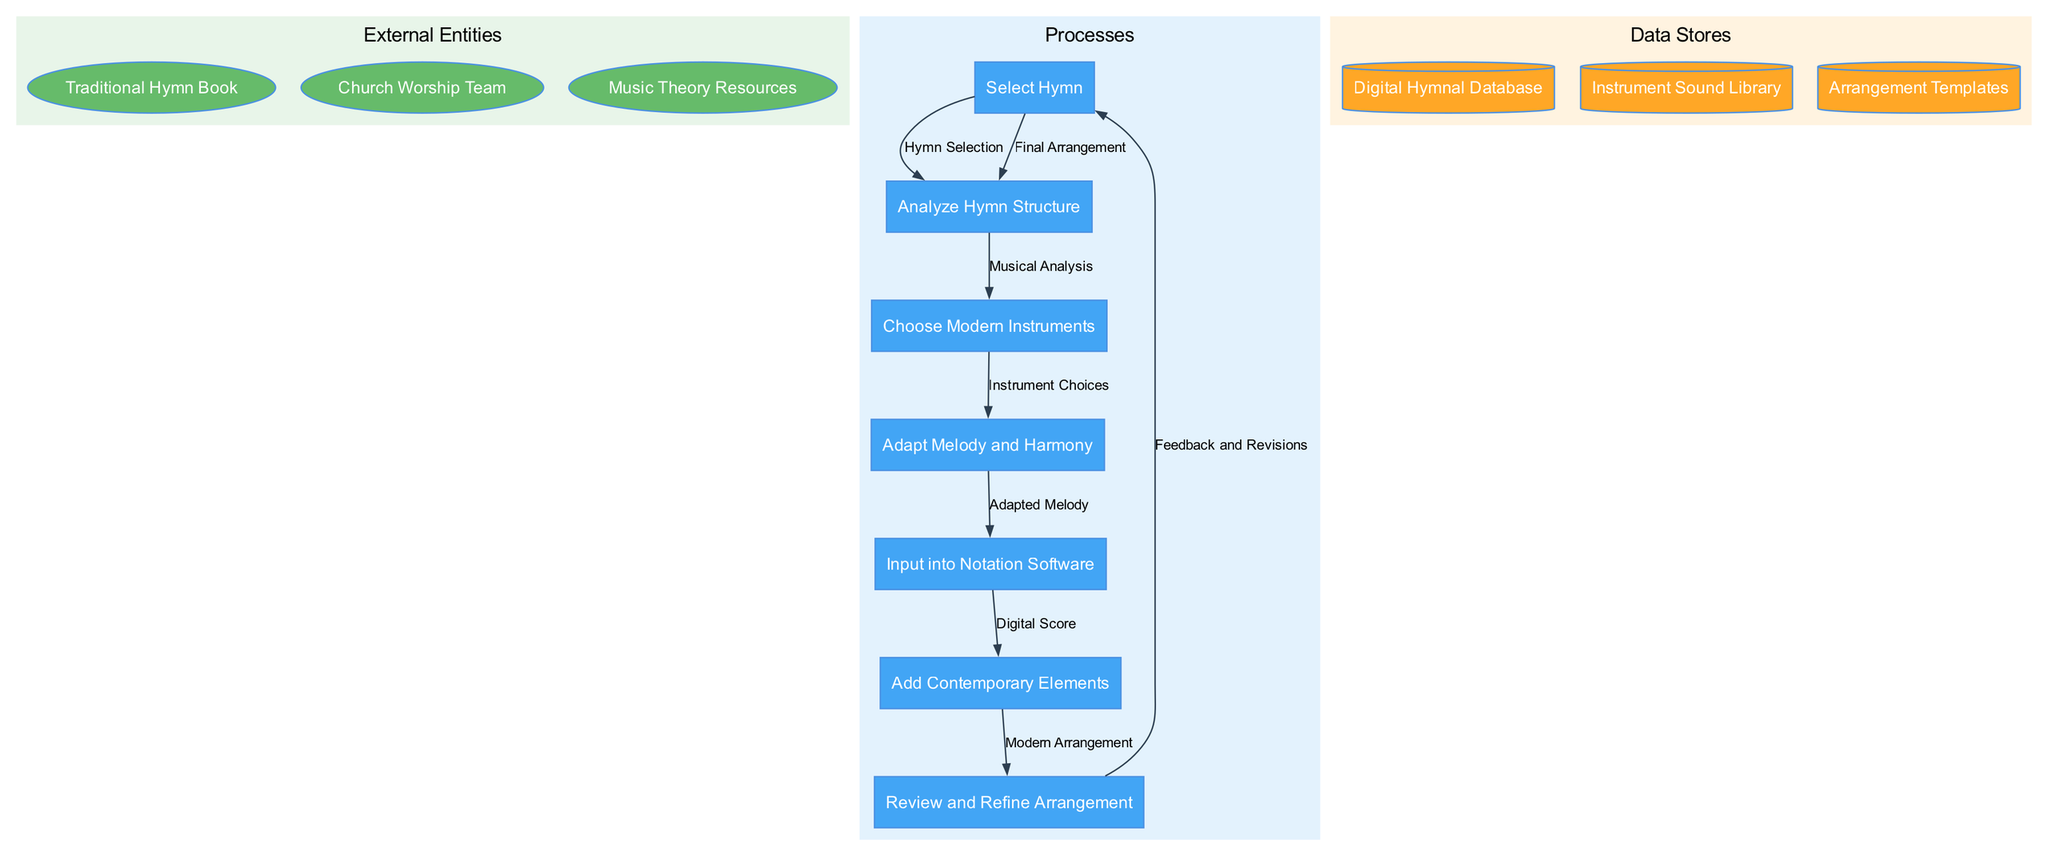What is the first process in the diagram? The first process listed in the diagram is "Select Hymn," which is indicated as the starting point of the flow in the processes cluster.
Answer: Select Hymn How many external entities are present in the diagram? There are three external entities: "Traditional Hymn Book," "Church Worship Team," and "Music Theory Resources." The count can be verified by listing them.
Answer: 3 Which data store is related to modern instrument choices? The "Instrument Sound Library" data store is directly associated with the process of "Choose Modern Instruments." This can be inferred from the connection between this process and the data store.
Answer: Instrument Sound Library What process follows "Adapt Melody and Harmony"? The process that follows "Adapt Melody and Harmony" is "Input into Notation Software." This is determined by tracing the flow after the specified process.
Answer: Input into Notation Software How many data flows are shown in the diagram? There are seven data flows indicated in the diagram that connect various processes. This can be confirmed by counting the edges representing the flow of data between processes.
Answer: 7 What is the final output of the arrangement process? The final output from the arrangement process is "Final Arrangement." This result is derived from tracing the flow through the entire sequence of processes to the endpoint.
Answer: Final Arrangement Which process receives feedback for revisions? The "Review and Refine Arrangement" process receives feedback as denoted by the flow labeled "Feedback and Revisions," connecting this process to the feedback loop.
Answer: Review and Refine Arrangement What is the role of the "Digital Hymnal Database"? The "Digital Hymnal Database" serves as a data store that provides access to hymns, which are essential for the "Select Hymn" process. It supplies the necessary data for this initial step.
Answer: Access to hymns 